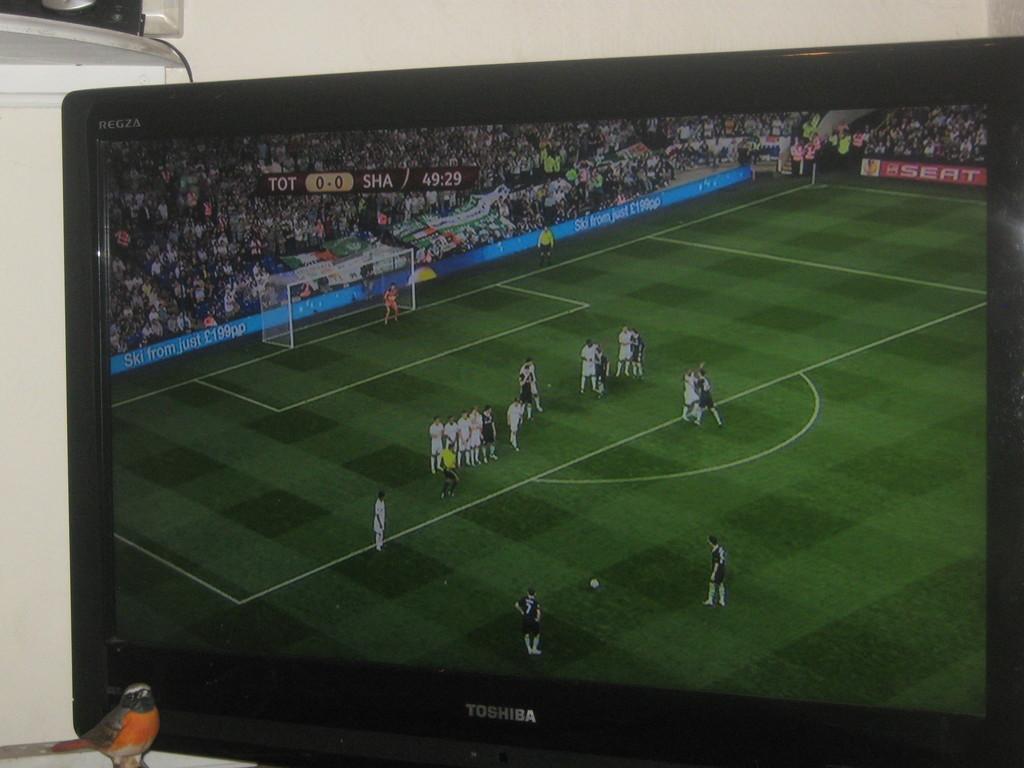In one or two sentences, can you explain what this image depicts? Here we can see a TV and at the bottom there is a toy bird on the left side. In the background on the left side there is an object on a stand and this is the wall. On the screen we can see a football match. 